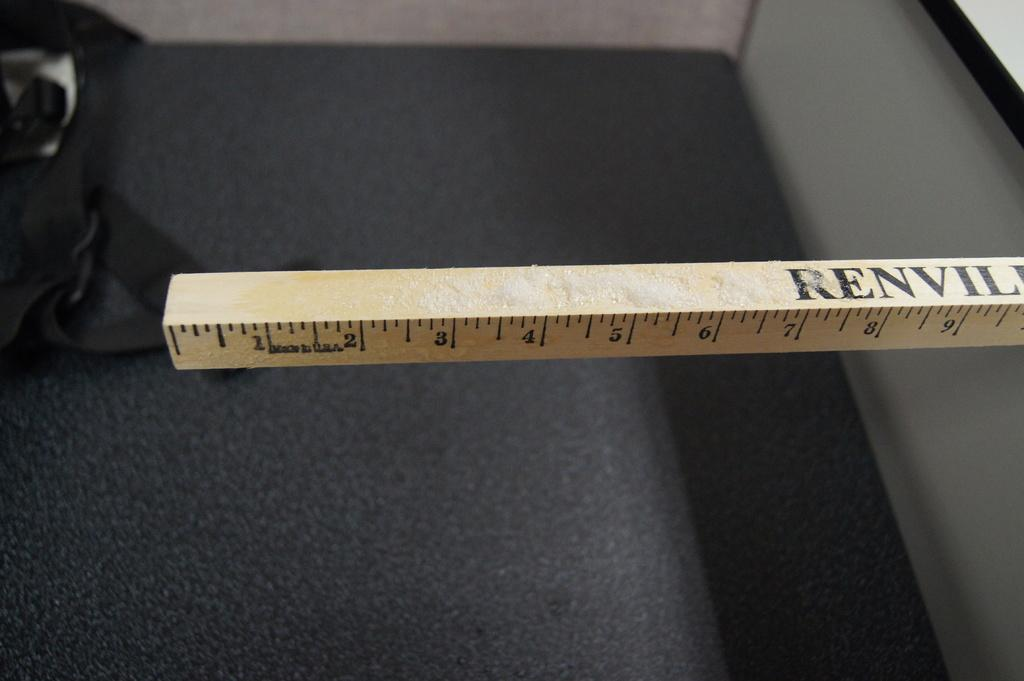Provide a one-sentence caption for the provided image. A brown ruler that is called renvil which is made in the USA. 